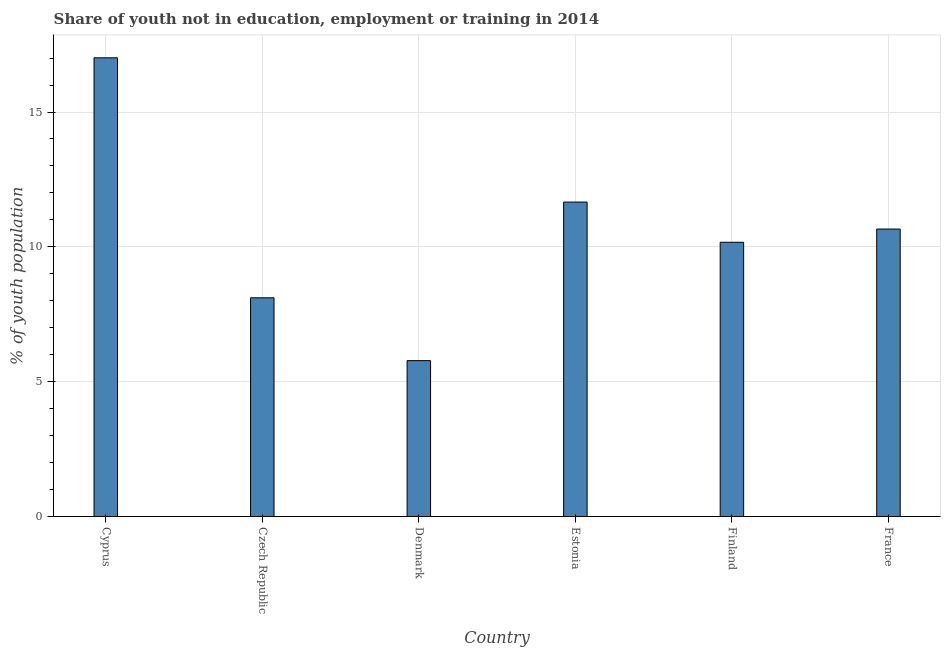Does the graph contain any zero values?
Ensure brevity in your answer.  No. What is the title of the graph?
Offer a very short reply. Share of youth not in education, employment or training in 2014. What is the label or title of the X-axis?
Your response must be concise. Country. What is the label or title of the Y-axis?
Your response must be concise. % of youth population. What is the unemployed youth population in Finland?
Offer a terse response. 10.17. Across all countries, what is the maximum unemployed youth population?
Ensure brevity in your answer.  17.01. Across all countries, what is the minimum unemployed youth population?
Offer a terse response. 5.78. In which country was the unemployed youth population maximum?
Make the answer very short. Cyprus. In which country was the unemployed youth population minimum?
Provide a short and direct response. Denmark. What is the sum of the unemployed youth population?
Ensure brevity in your answer.  63.39. What is the average unemployed youth population per country?
Keep it short and to the point. 10.56. What is the median unemployed youth population?
Provide a short and direct response. 10.41. What is the ratio of the unemployed youth population in Estonia to that in France?
Offer a very short reply. 1.09. Is the unemployed youth population in Estonia less than that in France?
Provide a short and direct response. No. What is the difference between the highest and the second highest unemployed youth population?
Ensure brevity in your answer.  5.35. What is the difference between the highest and the lowest unemployed youth population?
Keep it short and to the point. 11.23. How many countries are there in the graph?
Provide a short and direct response. 6. Are the values on the major ticks of Y-axis written in scientific E-notation?
Your response must be concise. No. What is the % of youth population of Cyprus?
Your answer should be very brief. 17.01. What is the % of youth population of Czech Republic?
Give a very brief answer. 8.11. What is the % of youth population of Denmark?
Keep it short and to the point. 5.78. What is the % of youth population of Estonia?
Offer a very short reply. 11.66. What is the % of youth population of Finland?
Provide a short and direct response. 10.17. What is the % of youth population of France?
Your response must be concise. 10.66. What is the difference between the % of youth population in Cyprus and Czech Republic?
Provide a succinct answer. 8.9. What is the difference between the % of youth population in Cyprus and Denmark?
Give a very brief answer. 11.23. What is the difference between the % of youth population in Cyprus and Estonia?
Make the answer very short. 5.35. What is the difference between the % of youth population in Cyprus and Finland?
Offer a very short reply. 6.84. What is the difference between the % of youth population in Cyprus and France?
Make the answer very short. 6.35. What is the difference between the % of youth population in Czech Republic and Denmark?
Make the answer very short. 2.33. What is the difference between the % of youth population in Czech Republic and Estonia?
Provide a short and direct response. -3.55. What is the difference between the % of youth population in Czech Republic and Finland?
Give a very brief answer. -2.06. What is the difference between the % of youth population in Czech Republic and France?
Ensure brevity in your answer.  -2.55. What is the difference between the % of youth population in Denmark and Estonia?
Offer a terse response. -5.88. What is the difference between the % of youth population in Denmark and Finland?
Offer a terse response. -4.39. What is the difference between the % of youth population in Denmark and France?
Offer a very short reply. -4.88. What is the difference between the % of youth population in Estonia and Finland?
Give a very brief answer. 1.49. What is the difference between the % of youth population in Finland and France?
Keep it short and to the point. -0.49. What is the ratio of the % of youth population in Cyprus to that in Czech Republic?
Make the answer very short. 2.1. What is the ratio of the % of youth population in Cyprus to that in Denmark?
Make the answer very short. 2.94. What is the ratio of the % of youth population in Cyprus to that in Estonia?
Your answer should be compact. 1.46. What is the ratio of the % of youth population in Cyprus to that in Finland?
Provide a succinct answer. 1.67. What is the ratio of the % of youth population in Cyprus to that in France?
Offer a terse response. 1.6. What is the ratio of the % of youth population in Czech Republic to that in Denmark?
Give a very brief answer. 1.4. What is the ratio of the % of youth population in Czech Republic to that in Estonia?
Your answer should be very brief. 0.7. What is the ratio of the % of youth population in Czech Republic to that in Finland?
Provide a short and direct response. 0.8. What is the ratio of the % of youth population in Czech Republic to that in France?
Provide a succinct answer. 0.76. What is the ratio of the % of youth population in Denmark to that in Estonia?
Offer a terse response. 0.5. What is the ratio of the % of youth population in Denmark to that in Finland?
Provide a short and direct response. 0.57. What is the ratio of the % of youth population in Denmark to that in France?
Offer a terse response. 0.54. What is the ratio of the % of youth population in Estonia to that in Finland?
Your answer should be compact. 1.15. What is the ratio of the % of youth population in Estonia to that in France?
Offer a very short reply. 1.09. What is the ratio of the % of youth population in Finland to that in France?
Your answer should be very brief. 0.95. 